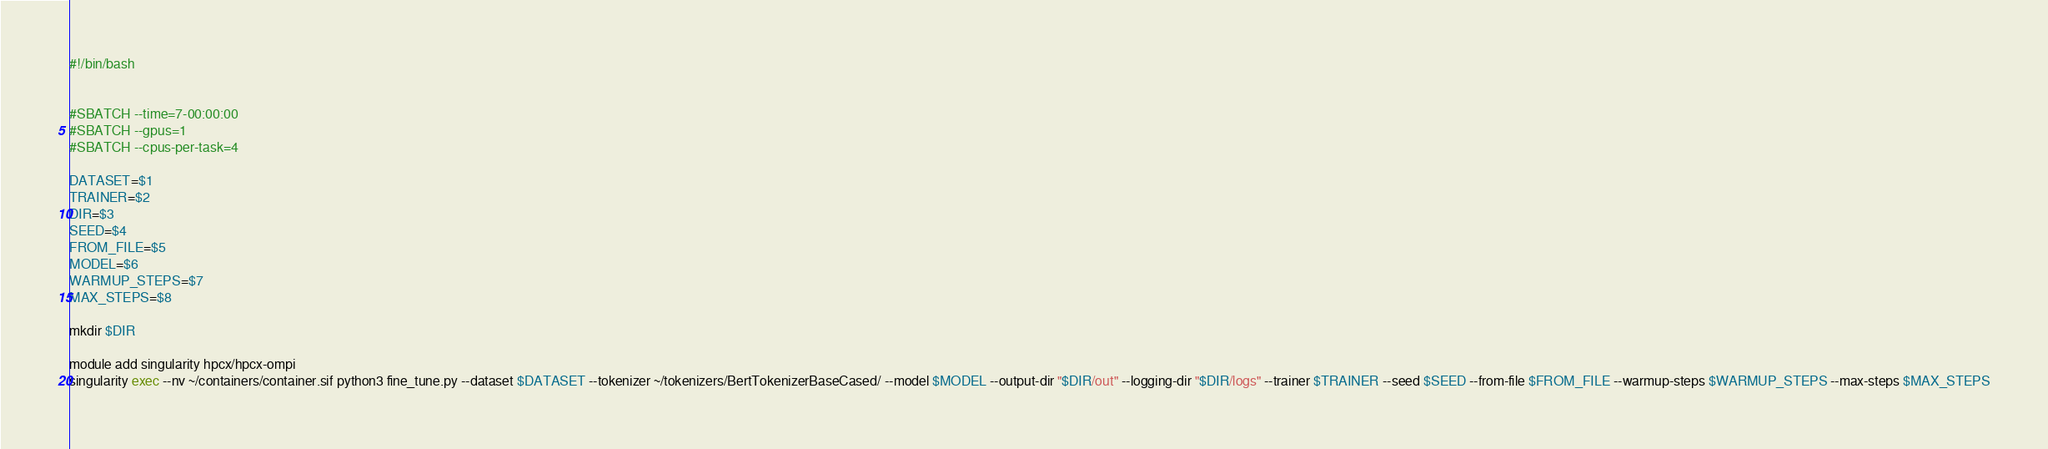Convert code to text. <code><loc_0><loc_0><loc_500><loc_500><_Bash_>#!/bin/bash


#SBATCH --time=7-00:00:00
#SBATCH --gpus=1
#SBATCH --cpus-per-task=4

DATASET=$1
TRAINER=$2
DIR=$3
SEED=$4
FROM_FILE=$5
MODEL=$6
WARMUP_STEPS=$7
MAX_STEPS=$8

mkdir $DIR

module add singularity hpcx/hpcx-ompi
singularity exec --nv ~/containers/container.sif python3 fine_tune.py --dataset $DATASET --tokenizer ~/tokenizers/BertTokenizerBaseCased/ --model $MODEL --output-dir "$DIR/out" --logging-dir "$DIR/logs" --trainer $TRAINER --seed $SEED --from-file $FROM_FILE --warmup-steps $WARMUP_STEPS --max-steps $MAX_STEPS

</code> 